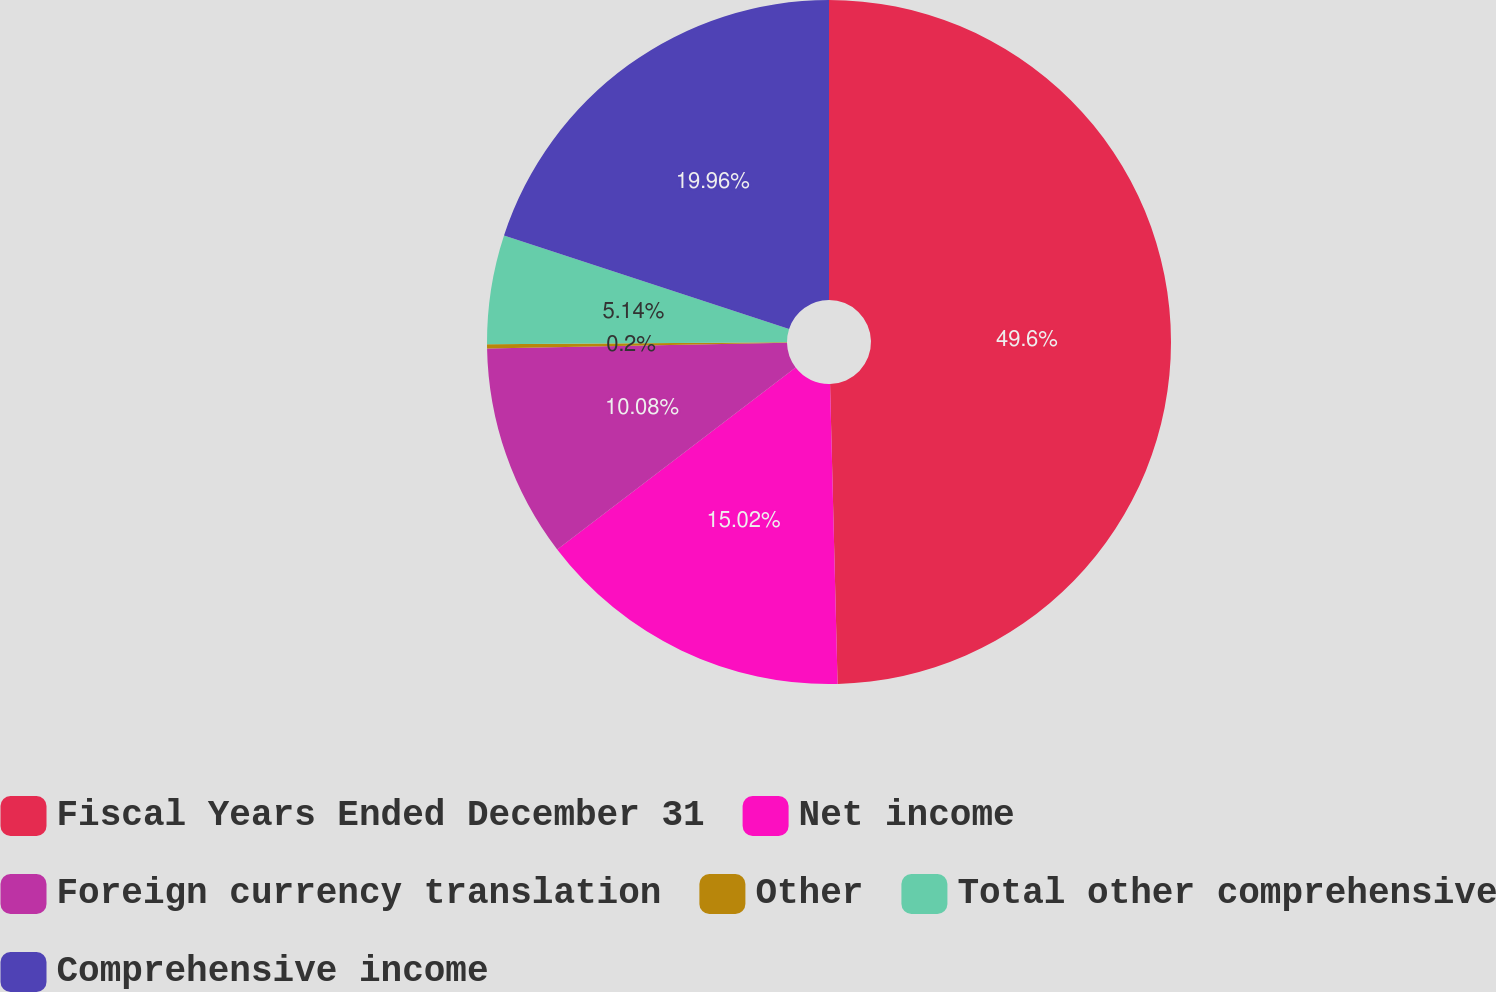<chart> <loc_0><loc_0><loc_500><loc_500><pie_chart><fcel>Fiscal Years Ended December 31<fcel>Net income<fcel>Foreign currency translation<fcel>Other<fcel>Total other comprehensive<fcel>Comprehensive income<nl><fcel>49.6%<fcel>15.02%<fcel>10.08%<fcel>0.2%<fcel>5.14%<fcel>19.96%<nl></chart> 